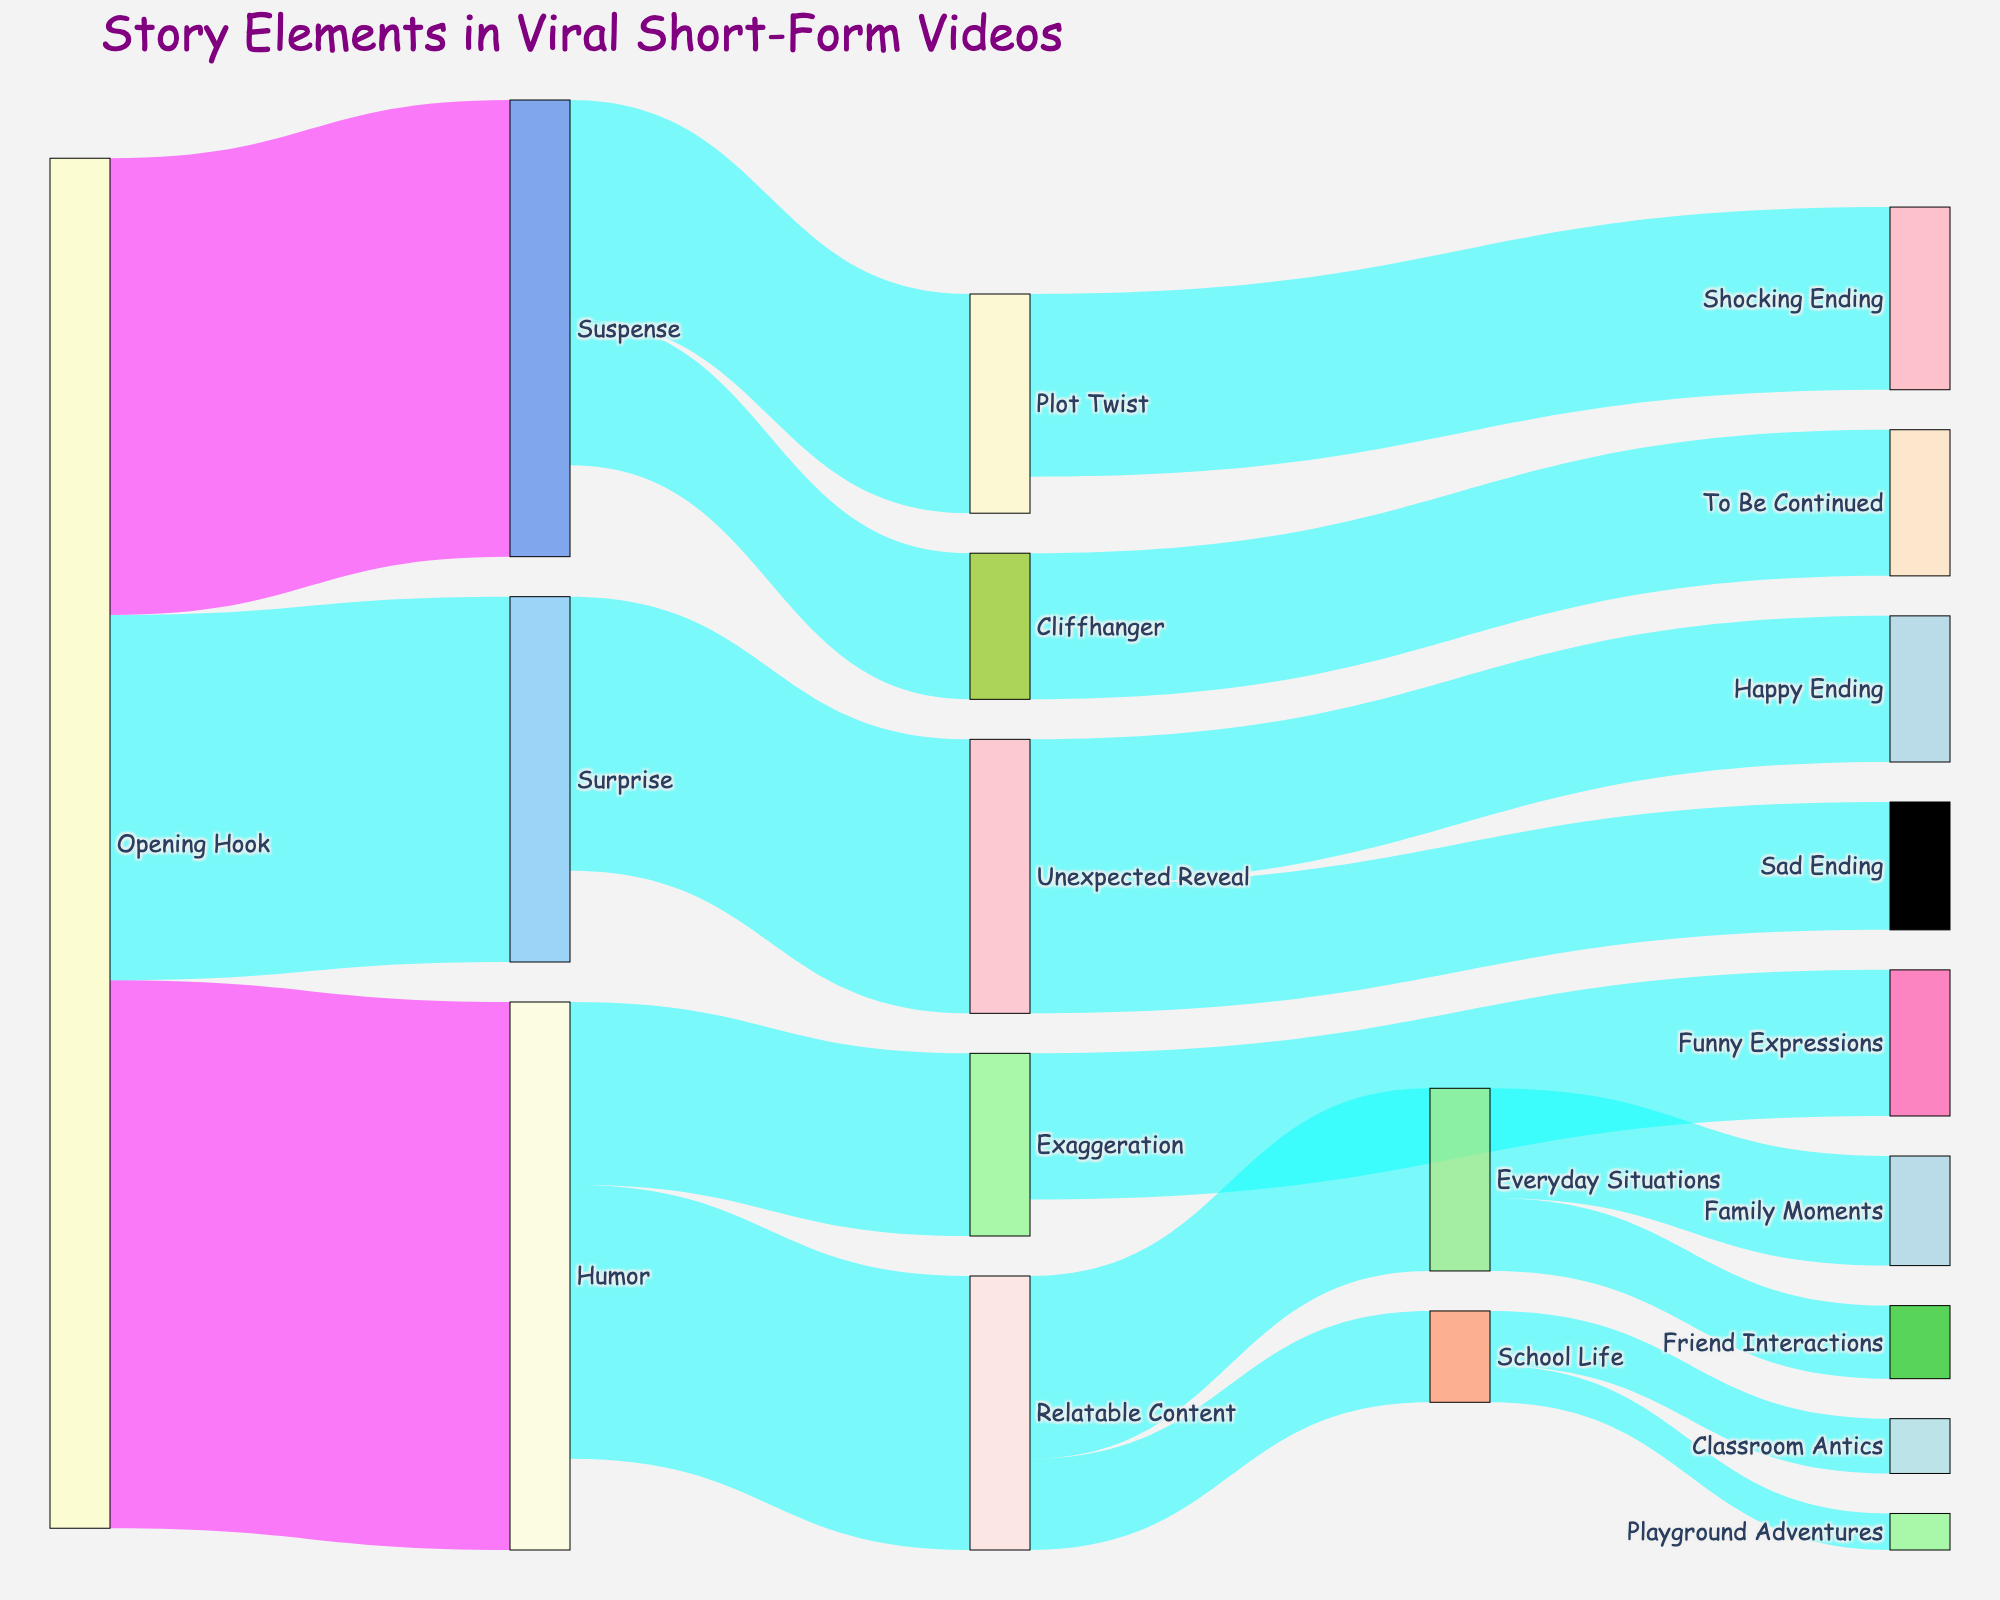What is the title of the Sankey diagram? The title of the diagram is displayed at the top center of the figure.
Answer: Story Elements in Viral Short-Form Videos Which story element has the highest initial value flowing into it from the Opening Hook? By examining the connections from the Opening Hook, the thickest link represents the highest value flowing into Humor, which is 30.
Answer: Humor What are the two types of content that Humor is connected to? The nodes linked to Humor contain labels showing Relatable Content and Exaggeration.
Answer: Relatable Content, Exaggeration How many elements flow into Relatable Content? By counting the connections leading to Relatable Content, there are two: one from Humor (15) and one from Everyday Situations (10).
Answer: 2 What is the total value of elements flowing from Suspense? Sum the values of connections originating from Suspense, including Plot Twist (12) and Cliffhanger (8). 12 + 8 = 20
Answer: 20 Which concluding story element connects both to Unexpected Reveal? Examine the connections from Unexpected Reveal to find two endpoints: Happy Ending (8) and Sad Ending (7).
Answer: Happy Ending, Sad Ending Compare the value differences between Shocking Ending and To Be Continued under their respective sources. Shocking Ending (10) originates from Plot Twist while To Be Continued (8) from Cliffhanger. So the difference is 10 - 8 = 2
Answer: 2 What value connects School Life to Playground Adventures, and how does that compare to the same link's connection from Classroom Antics? The value connection for Playground Adventures is 2, and Classroom Antics is 3. Comparing, Playground Adventures is 1 less than Classroom Antics.
Answer: 2, Playground Adventures is 1 less What are the colors used for distinguishing connections with high values? The color for connections with values greater than 20 is distinct from others. Specifically, high-value connections are marked with shades of magenta (pinkish).
Answer: shades of magenta 